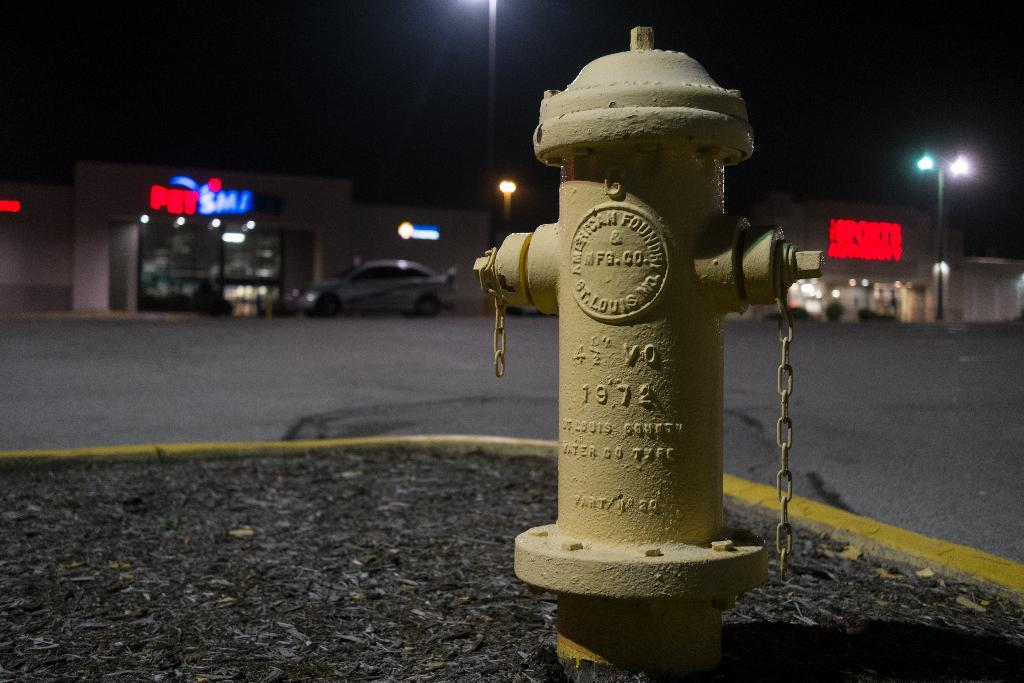What type of establishments can be seen in the background of the image? There are stores in the background of the image. What else is visible in the background of the image? There are lights in the background of the image. Can you describe the car's location in the image? The car is near a store in the image. What object can be seen in the image that is typically used for firefighting? There is a hydrant in the image. What type of vase can be seen in the image? There is no vase present in the image. What activity is taking place in the image? The image does not depict any specific activity; it shows a car near a store, a hydrant, and lights in the background. 